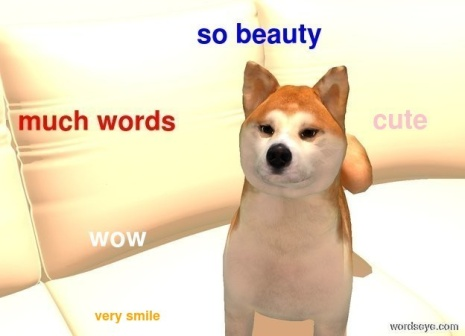What is this photo about? The image shows a Shiba Inu dog, recognized for its fox-like appearance and lively personality, comfortably positioned on a white couch. The dog is looking directly at the camera, its eyes sparkling with playfulness, and a slight, charming smile on its face. Surrounding the dog are colorful floating words such as "so beauty", "much words", "cute", "WOW", and "very smile". These words add a whimsical and humorous touch to the scene, highlighting the dog's endearing attributes. The neutral white background emphasizes the dog and the playful text, making them the focal point of the image. Overall, the picture presents a light-hearted and entertaining moment with the Shiba Inu as the centerpiece. 